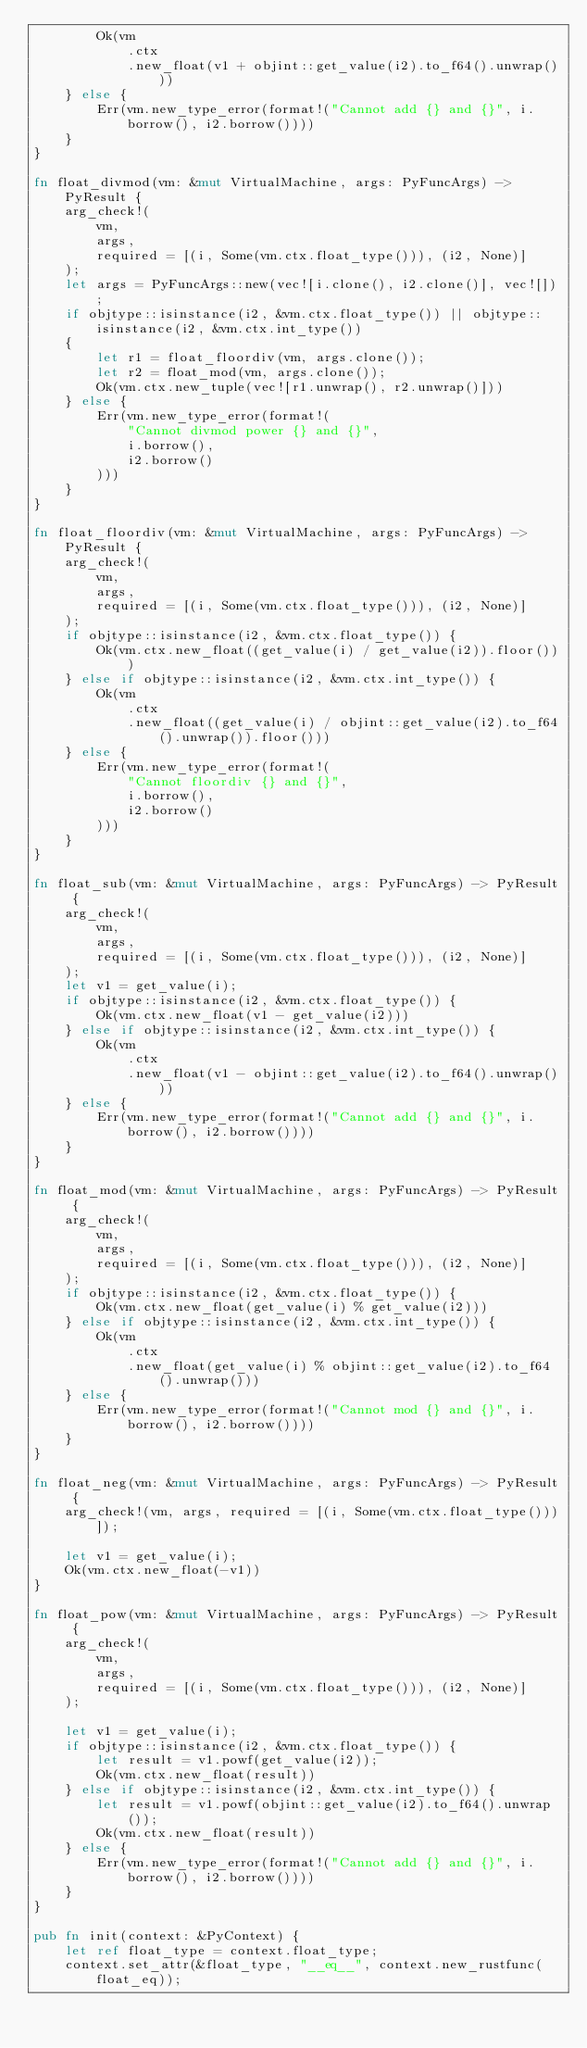<code> <loc_0><loc_0><loc_500><loc_500><_Rust_>        Ok(vm
            .ctx
            .new_float(v1 + objint::get_value(i2).to_f64().unwrap()))
    } else {
        Err(vm.new_type_error(format!("Cannot add {} and {}", i.borrow(), i2.borrow())))
    }
}

fn float_divmod(vm: &mut VirtualMachine, args: PyFuncArgs) -> PyResult {
    arg_check!(
        vm,
        args,
        required = [(i, Some(vm.ctx.float_type())), (i2, None)]
    );
    let args = PyFuncArgs::new(vec![i.clone(), i2.clone()], vec![]);
    if objtype::isinstance(i2, &vm.ctx.float_type()) || objtype::isinstance(i2, &vm.ctx.int_type())
    {
        let r1 = float_floordiv(vm, args.clone());
        let r2 = float_mod(vm, args.clone());
        Ok(vm.ctx.new_tuple(vec![r1.unwrap(), r2.unwrap()]))
    } else {
        Err(vm.new_type_error(format!(
            "Cannot divmod power {} and {}",
            i.borrow(),
            i2.borrow()
        )))
    }
}

fn float_floordiv(vm: &mut VirtualMachine, args: PyFuncArgs) -> PyResult {
    arg_check!(
        vm,
        args,
        required = [(i, Some(vm.ctx.float_type())), (i2, None)]
    );
    if objtype::isinstance(i2, &vm.ctx.float_type()) {
        Ok(vm.ctx.new_float((get_value(i) / get_value(i2)).floor()))
    } else if objtype::isinstance(i2, &vm.ctx.int_type()) {
        Ok(vm
            .ctx
            .new_float((get_value(i) / objint::get_value(i2).to_f64().unwrap()).floor()))
    } else {
        Err(vm.new_type_error(format!(
            "Cannot floordiv {} and {}",
            i.borrow(),
            i2.borrow()
        )))
    }
}

fn float_sub(vm: &mut VirtualMachine, args: PyFuncArgs) -> PyResult {
    arg_check!(
        vm,
        args,
        required = [(i, Some(vm.ctx.float_type())), (i2, None)]
    );
    let v1 = get_value(i);
    if objtype::isinstance(i2, &vm.ctx.float_type()) {
        Ok(vm.ctx.new_float(v1 - get_value(i2)))
    } else if objtype::isinstance(i2, &vm.ctx.int_type()) {
        Ok(vm
            .ctx
            .new_float(v1 - objint::get_value(i2).to_f64().unwrap()))
    } else {
        Err(vm.new_type_error(format!("Cannot add {} and {}", i.borrow(), i2.borrow())))
    }
}

fn float_mod(vm: &mut VirtualMachine, args: PyFuncArgs) -> PyResult {
    arg_check!(
        vm,
        args,
        required = [(i, Some(vm.ctx.float_type())), (i2, None)]
    );
    if objtype::isinstance(i2, &vm.ctx.float_type()) {
        Ok(vm.ctx.new_float(get_value(i) % get_value(i2)))
    } else if objtype::isinstance(i2, &vm.ctx.int_type()) {
        Ok(vm
            .ctx
            .new_float(get_value(i) % objint::get_value(i2).to_f64().unwrap()))
    } else {
        Err(vm.new_type_error(format!("Cannot mod {} and {}", i.borrow(), i2.borrow())))
    }
}

fn float_neg(vm: &mut VirtualMachine, args: PyFuncArgs) -> PyResult {
    arg_check!(vm, args, required = [(i, Some(vm.ctx.float_type()))]);

    let v1 = get_value(i);
    Ok(vm.ctx.new_float(-v1))
}

fn float_pow(vm: &mut VirtualMachine, args: PyFuncArgs) -> PyResult {
    arg_check!(
        vm,
        args,
        required = [(i, Some(vm.ctx.float_type())), (i2, None)]
    );

    let v1 = get_value(i);
    if objtype::isinstance(i2, &vm.ctx.float_type()) {
        let result = v1.powf(get_value(i2));
        Ok(vm.ctx.new_float(result))
    } else if objtype::isinstance(i2, &vm.ctx.int_type()) {
        let result = v1.powf(objint::get_value(i2).to_f64().unwrap());
        Ok(vm.ctx.new_float(result))
    } else {
        Err(vm.new_type_error(format!("Cannot add {} and {}", i.borrow(), i2.borrow())))
    }
}

pub fn init(context: &PyContext) {
    let ref float_type = context.float_type;
    context.set_attr(&float_type, "__eq__", context.new_rustfunc(float_eq));</code> 